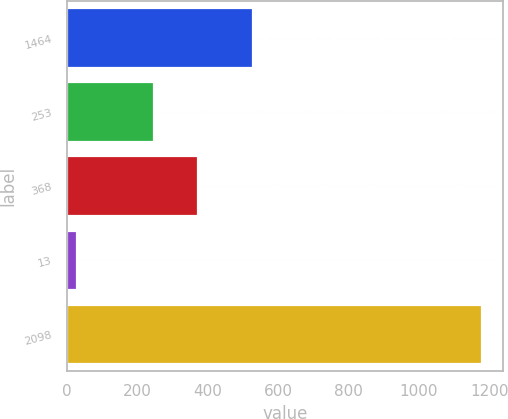<chart> <loc_0><loc_0><loc_500><loc_500><bar_chart><fcel>1464<fcel>253<fcel>368<fcel>13<fcel>2098<nl><fcel>529<fcel>247<fcel>372<fcel>31<fcel>1179<nl></chart> 